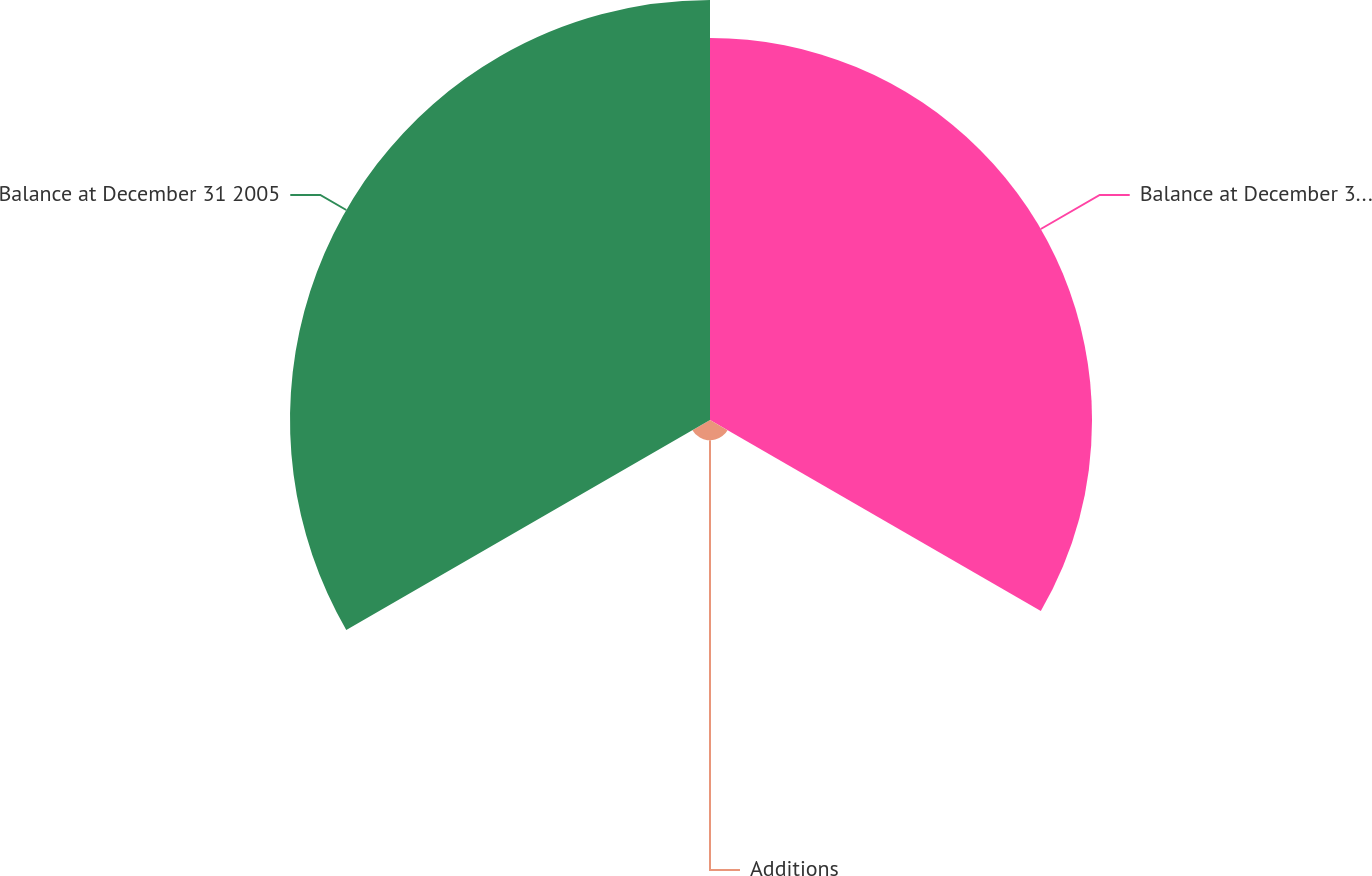Convert chart. <chart><loc_0><loc_0><loc_500><loc_500><pie_chart><fcel>Balance at December 31 2004<fcel>Additions<fcel>Balance at December 31 2005<nl><fcel>46.46%<fcel>2.47%<fcel>51.08%<nl></chart> 